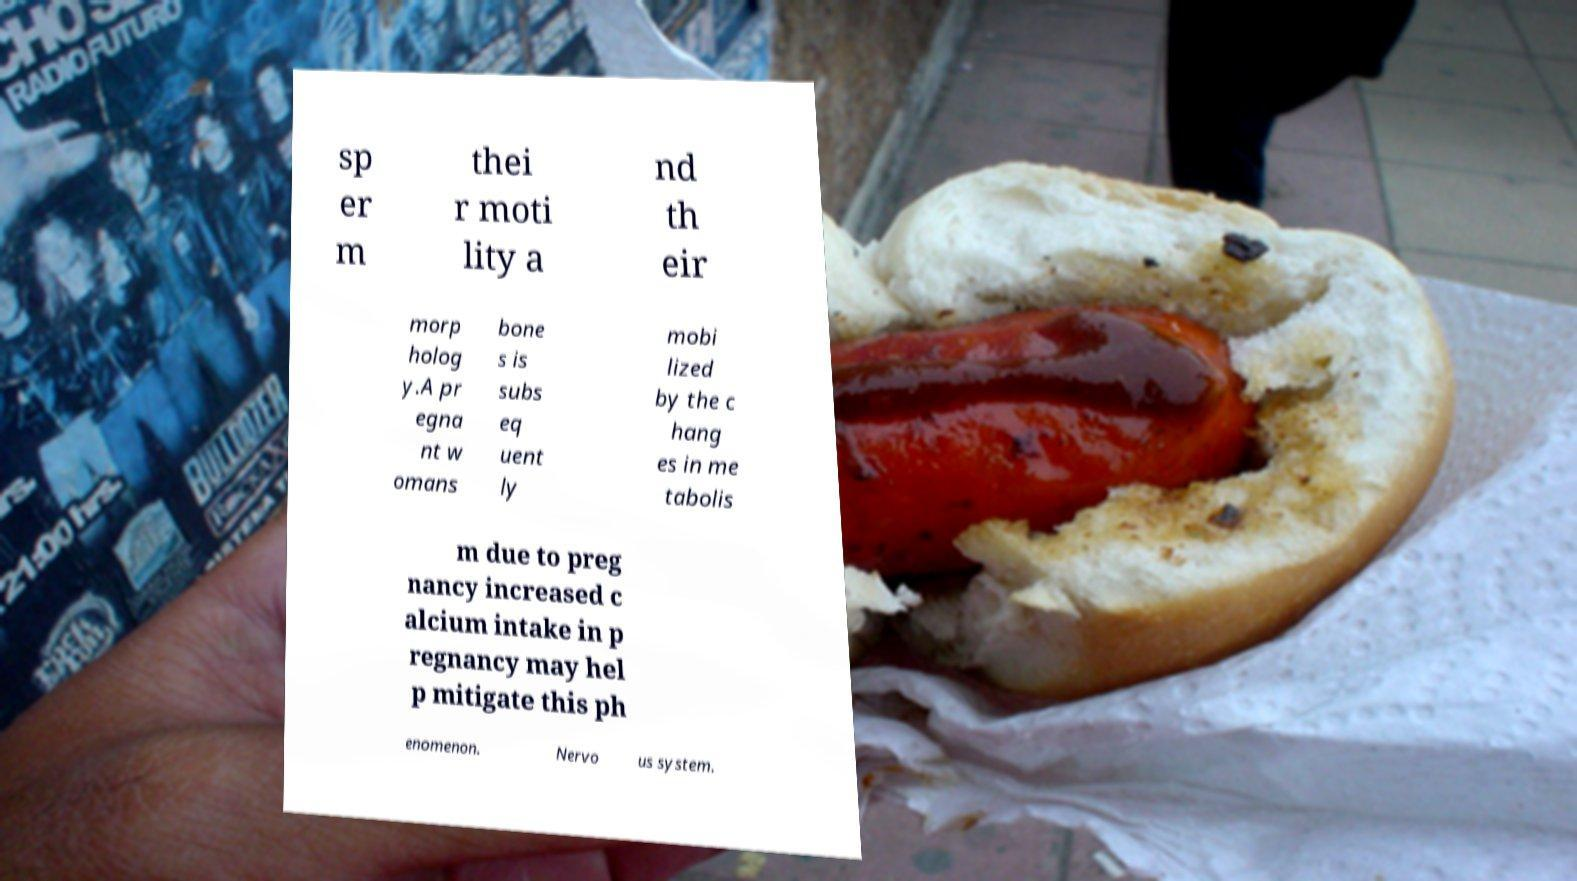Please identify and transcribe the text found in this image. sp er m thei r moti lity a nd th eir morp holog y.A pr egna nt w omans bone s is subs eq uent ly mobi lized by the c hang es in me tabolis m due to preg nancy increased c alcium intake in p regnancy may hel p mitigate this ph enomenon. Nervo us system. 